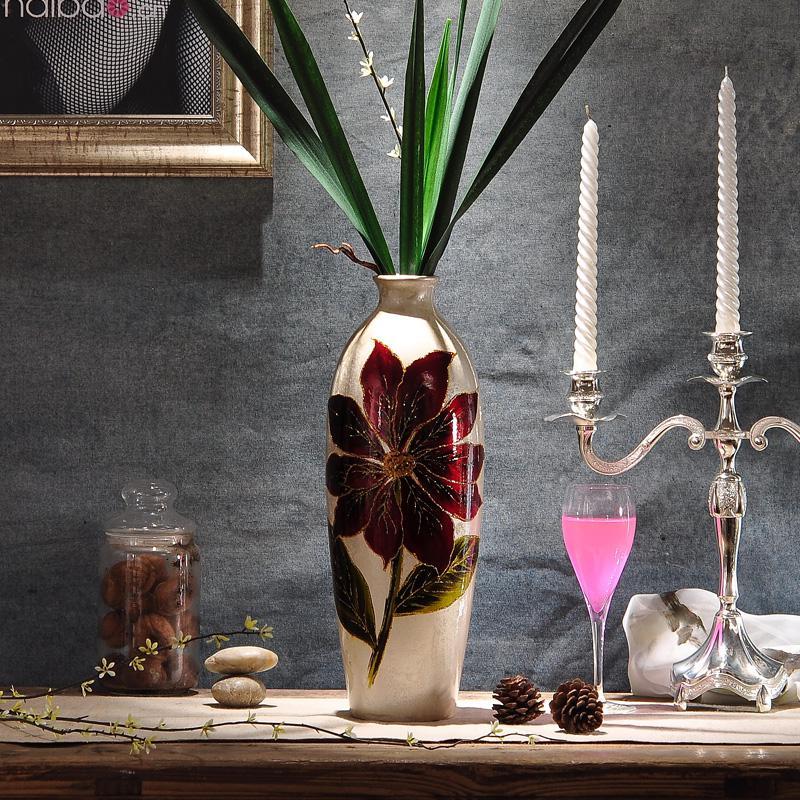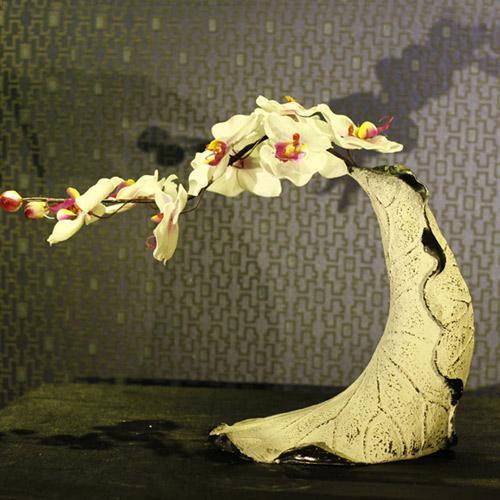The first image is the image on the left, the second image is the image on the right. For the images shown, is this caption "There are three white vases with flowers in the image on the right." true? Answer yes or no. No. 